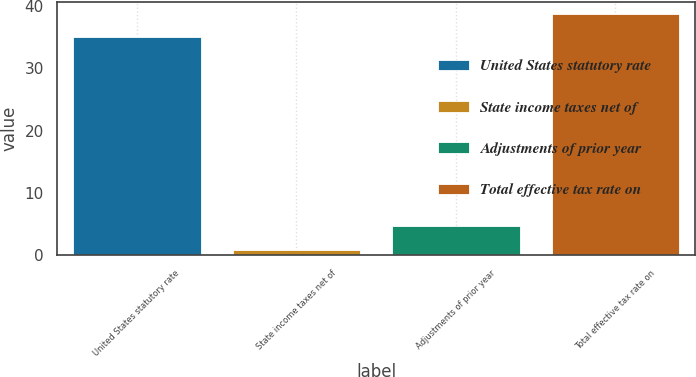<chart> <loc_0><loc_0><loc_500><loc_500><bar_chart><fcel>United States statutory rate<fcel>State income taxes net of<fcel>Adjustments of prior year<fcel>Total effective tax rate on<nl><fcel>35<fcel>0.9<fcel>4.63<fcel>38.73<nl></chart> 